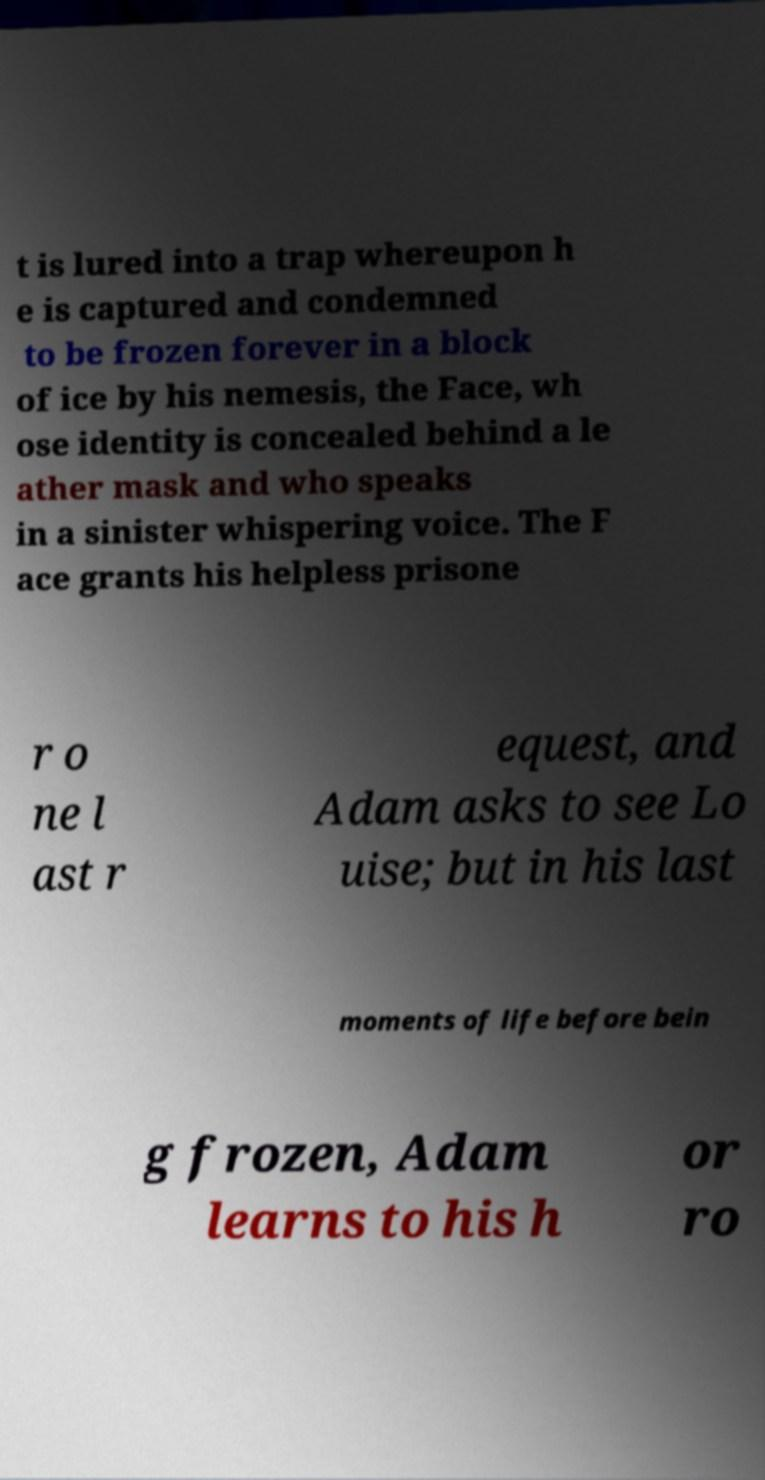Could you assist in decoding the text presented in this image and type it out clearly? t is lured into a trap whereupon h e is captured and condemned to be frozen forever in a block of ice by his nemesis, the Face, wh ose identity is concealed behind a le ather mask and who speaks in a sinister whispering voice. The F ace grants his helpless prisone r o ne l ast r equest, and Adam asks to see Lo uise; but in his last moments of life before bein g frozen, Adam learns to his h or ro 